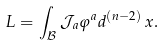<formula> <loc_0><loc_0><loc_500><loc_500>L = \int _ { \mathcal { B } } \mathcal { J } _ { a } \varphi ^ { a } d ^ { ( n - 2 ) } \, x .</formula> 